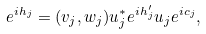Convert formula to latex. <formula><loc_0><loc_0><loc_500><loc_500>e ^ { i h _ { j } } = ( v _ { j } , w _ { j } ) u _ { j } ^ { * } e ^ { i h _ { j } ^ { \prime } } u _ { j } e ^ { i c _ { j } } ,</formula> 